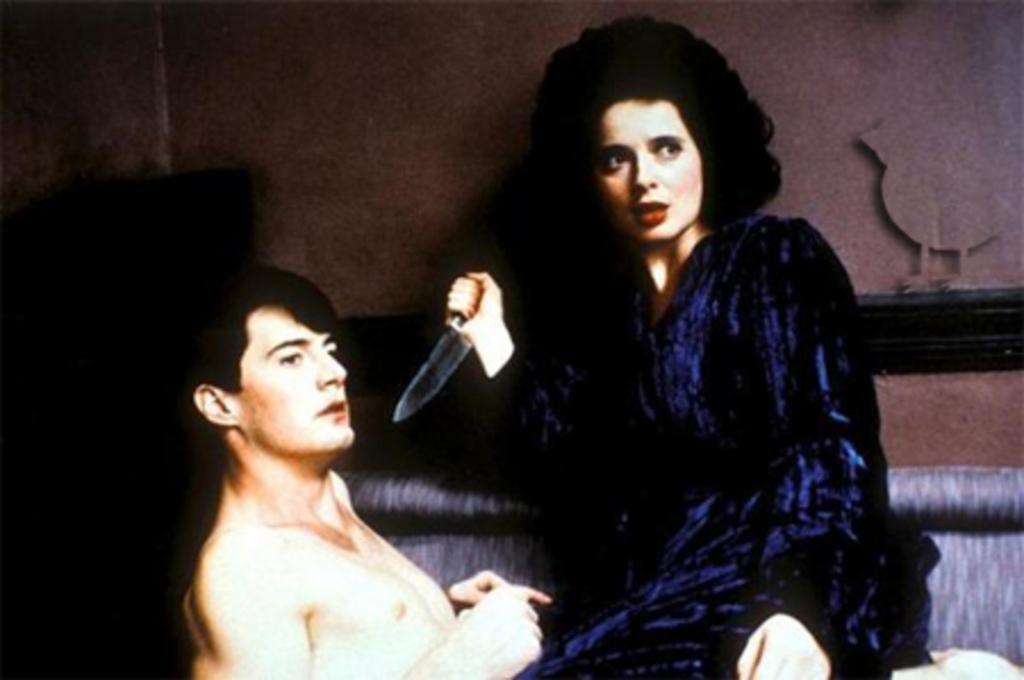Describe this image in one or two sentences. In this picture there is a woman who is wearing black dress and holding a knife. She is sitting on this person's stomach and he is lying on the couch. In the back we can see the wall. On the top right there is a bird´statue. 